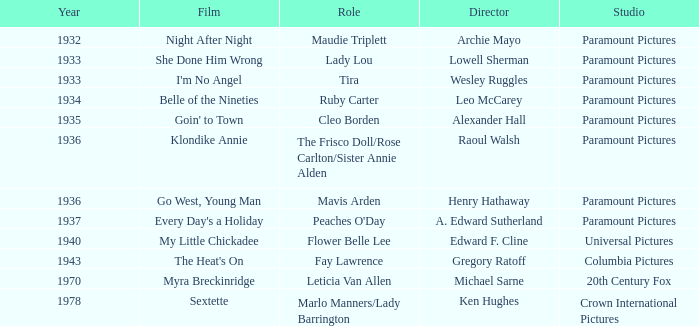Could you help me parse every detail presented in this table? {'header': ['Year', 'Film', 'Role', 'Director', 'Studio'], 'rows': [['1932', 'Night After Night', 'Maudie Triplett', 'Archie Mayo', 'Paramount Pictures'], ['1933', 'She Done Him Wrong', 'Lady Lou', 'Lowell Sherman', 'Paramount Pictures'], ['1933', "I'm No Angel", 'Tira', 'Wesley Ruggles', 'Paramount Pictures'], ['1934', 'Belle of the Nineties', 'Ruby Carter', 'Leo McCarey', 'Paramount Pictures'], ['1935', "Goin' to Town", 'Cleo Borden', 'Alexander Hall', 'Paramount Pictures'], ['1936', 'Klondike Annie', 'The Frisco Doll/Rose Carlton/Sister Annie Alden', 'Raoul Walsh', 'Paramount Pictures'], ['1936', 'Go West, Young Man', 'Mavis Arden', 'Henry Hathaway', 'Paramount Pictures'], ['1937', "Every Day's a Holiday", "Peaches O'Day", 'A. Edward Sutherland', 'Paramount Pictures'], ['1940', 'My Little Chickadee', 'Flower Belle Lee', 'Edward F. Cline', 'Universal Pictures'], ['1943', "The Heat's On", 'Fay Lawrence', 'Gregory Ratoff', 'Columbia Pictures'], ['1970', 'Myra Breckinridge', 'Leticia Van Allen', 'Michael Sarne', '20th Century Fox'], ['1978', 'Sextette', 'Marlo Manners/Lady Barrington', 'Ken Hughes', 'Crown International Pictures']]} What is the Year of the Film Klondike Annie? 1936.0. 